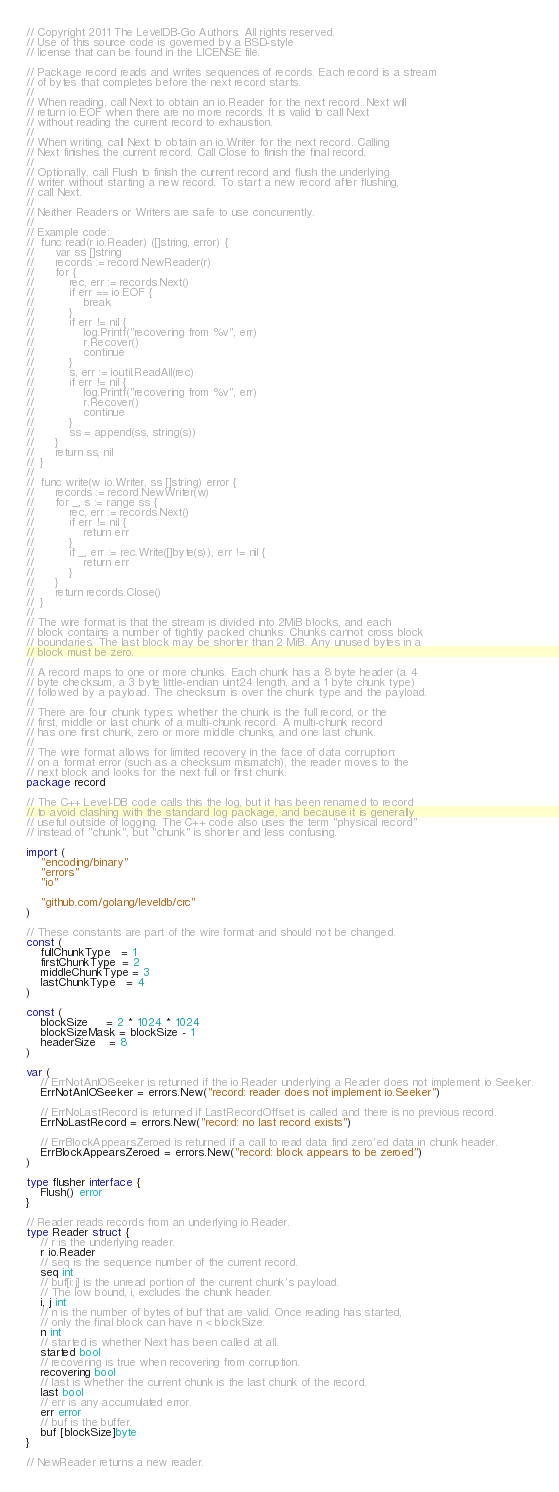<code> <loc_0><loc_0><loc_500><loc_500><_Go_>// Copyright 2011 The LevelDB-Go Authors. All rights reserved.
// Use of this source code is governed by a BSD-style
// license that can be found in the LICENSE file.

// Package record reads and writes sequences of records. Each record is a stream
// of bytes that completes before the next record starts.
//
// When reading, call Next to obtain an io.Reader for the next record. Next will
// return io.EOF when there are no more records. It is valid to call Next
// without reading the current record to exhaustion.
//
// When writing, call Next to obtain an io.Writer for the next record. Calling
// Next finishes the current record. Call Close to finish the final record.
//
// Optionally, call Flush to finish the current record and flush the underlying
// writer without starting a new record. To start a new record after flushing,
// call Next.
//
// Neither Readers or Writers are safe to use concurrently.
//
// Example code:
//	func read(r io.Reader) ([]string, error) {
//		var ss []string
//		records := record.NewReader(r)
//		for {
//			rec, err := records.Next()
//			if err == io.EOF {
//				break
//			}
//			if err != nil {
//				log.Printf("recovering from %v", err)
//				r.Recover()
//				continue
//			}
//			s, err := ioutil.ReadAll(rec)
//			if err != nil {
//				log.Printf("recovering from %v", err)
//				r.Recover()
//				continue
//			}
//			ss = append(ss, string(s))
//		}
//		return ss, nil
//	}
//
//	func write(w io.Writer, ss []string) error {
//		records := record.NewWriter(w)
//		for _, s := range ss {
//			rec, err := records.Next()
//			if err != nil {
//				return err
//			}
//			if _, err := rec.Write([]byte(s)), err != nil {
//				return err
//			}
//		}
//		return records.Close()
//	}
//
// The wire format is that the stream is divided into 2MiB blocks, and each
// block contains a number of tightly packed chunks. Chunks cannot cross block
// boundaries. The last block may be shorter than 2 MiB. Any unused bytes in a
// block must be zero.
//
// A record maps to one or more chunks. Each chunk has a 8 byte header (a 4
// byte checksum, a 3 byte little-endian uint24 length, and a 1 byte chunk type)
// followed by a payload. The checksum is over the chunk type and the payload.
//
// There are four chunk types: whether the chunk is the full record, or the
// first, middle or last chunk of a multi-chunk record. A multi-chunk record
// has one first chunk, zero or more middle chunks, and one last chunk.
//
// The wire format allows for limited recovery in the face of data corruption:
// on a format error (such as a checksum mismatch), the reader moves to the
// next block and looks for the next full or first chunk.
package record

// The C++ Level-DB code calls this the log, but it has been renamed to record
// to avoid clashing with the standard log package, and because it is generally
// useful outside of logging. The C++ code also uses the term "physical record"
// instead of "chunk", but "chunk" is shorter and less confusing.

import (
	"encoding/binary"
	"errors"
	"io"

	"github.com/golang/leveldb/crc"
)

// These constants are part of the wire format and should not be changed.
const (
	fullChunkType   = 1
	firstChunkType  = 2
	middleChunkType = 3
	lastChunkType   = 4
)

const (
	blockSize     = 2 * 1024 * 1024
	blockSizeMask = blockSize - 1
	headerSize    = 8
)

var (
	// ErrNotAnIOSeeker is returned if the io.Reader underlying a Reader does not implement io.Seeker.
	ErrNotAnIOSeeker = errors.New("record: reader does not implement io.Seeker")

	// ErrNoLastRecord is returned if LastRecordOffset is called and there is no previous record.
	ErrNoLastRecord = errors.New("record: no last record exists")

	// ErrBlockAppearsZeroed is returned if a call to read data find zero'ed data in chunk header.
	ErrBlockAppearsZeroed = errors.New("record: block appears to be zeroed")
)

type flusher interface {
	Flush() error
}

// Reader reads records from an underlying io.Reader.
type Reader struct {
	// r is the underlying reader.
	r io.Reader
	// seq is the sequence number of the current record.
	seq int
	// buf[i:j] is the unread portion of the current chunk's payload.
	// The low bound, i, excludes the chunk header.
	i, j int
	// n is the number of bytes of buf that are valid. Once reading has started,
	// only the final block can have n < blockSize.
	n int
	// started is whether Next has been called at all.
	started bool
	// recovering is true when recovering from corruption.
	recovering bool
	// last is whether the current chunk is the last chunk of the record.
	last bool
	// err is any accumulated error.
	err error
	// buf is the buffer.
	buf [blockSize]byte
}

// NewReader returns a new reader.</code> 